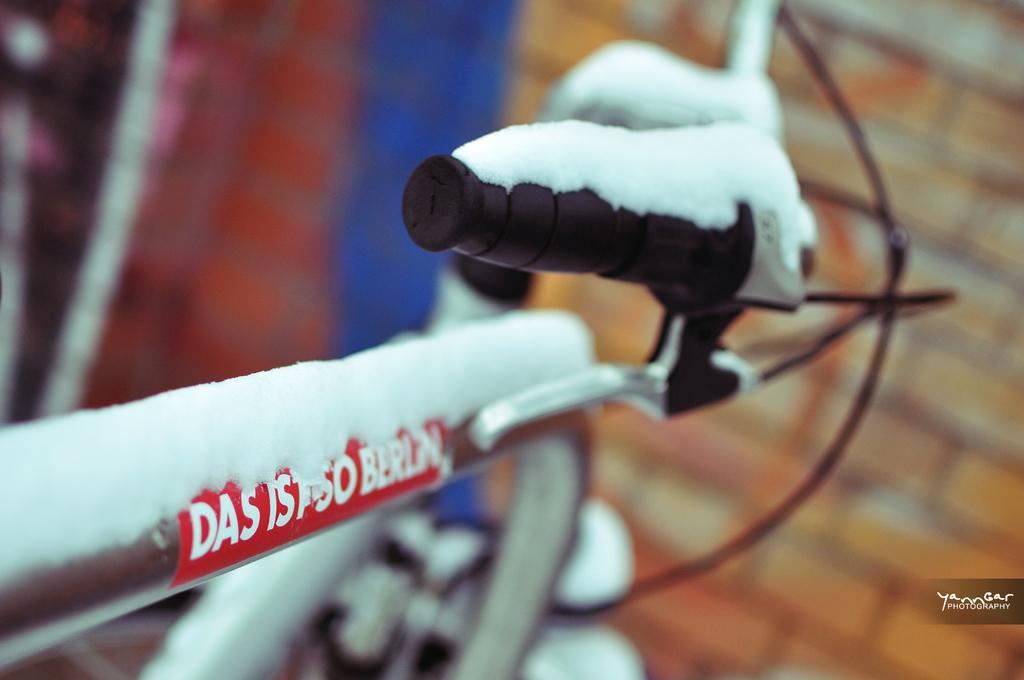What is the main object in the image? There is a bicycle in the image. What is covering the bicycle? Snow is present on the bicycle. What can be seen in the background of the image? There is a brick wall in the background of the image. How many lizards are sitting on the handlebars of the bicycle in the image? There are no lizards present in the image; the bicycle is covered in snow. What type of scarecrow is standing next to the brick wall in the image? There is no scarecrow present in the image; the background features a brick wall. 